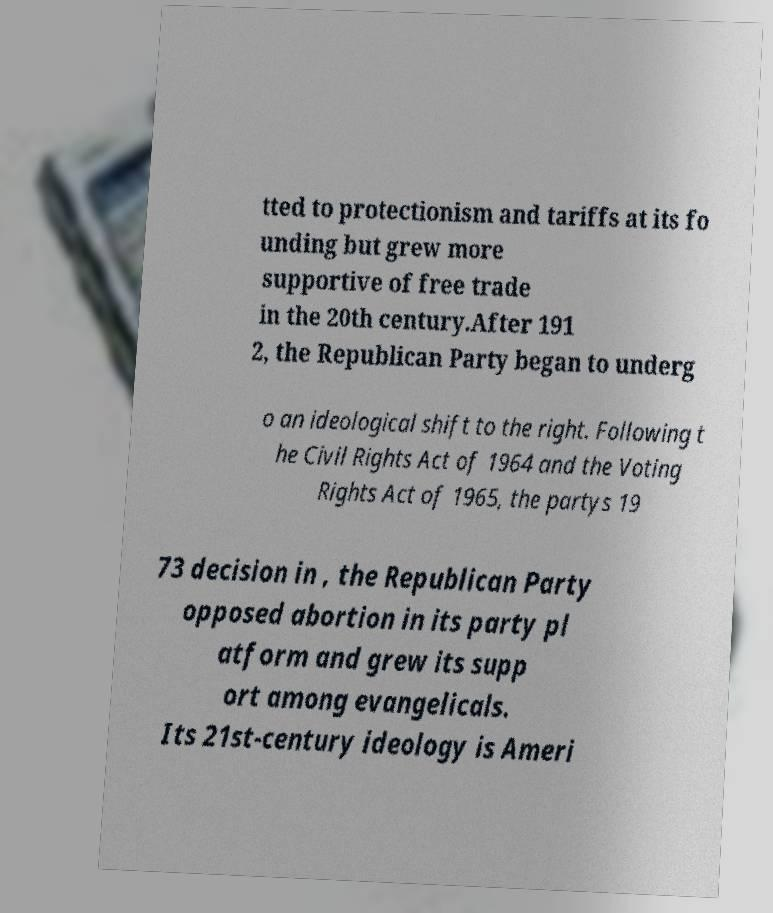Could you assist in decoding the text presented in this image and type it out clearly? tted to protectionism and tariffs at its fo unding but grew more supportive of free trade in the 20th century.After 191 2, the Republican Party began to underg o an ideological shift to the right. Following t he Civil Rights Act of 1964 and the Voting Rights Act of 1965, the partys 19 73 decision in , the Republican Party opposed abortion in its party pl atform and grew its supp ort among evangelicals. Its 21st-century ideology is Ameri 